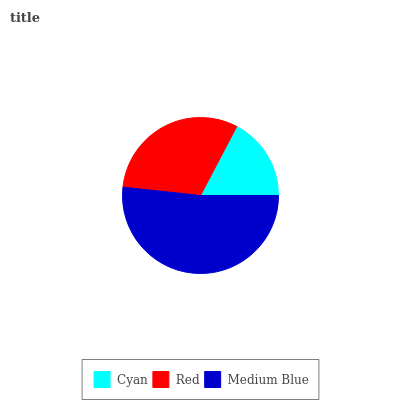Is Cyan the minimum?
Answer yes or no. Yes. Is Medium Blue the maximum?
Answer yes or no. Yes. Is Red the minimum?
Answer yes or no. No. Is Red the maximum?
Answer yes or no. No. Is Red greater than Cyan?
Answer yes or no. Yes. Is Cyan less than Red?
Answer yes or no. Yes. Is Cyan greater than Red?
Answer yes or no. No. Is Red less than Cyan?
Answer yes or no. No. Is Red the high median?
Answer yes or no. Yes. Is Red the low median?
Answer yes or no. Yes. Is Cyan the high median?
Answer yes or no. No. Is Cyan the low median?
Answer yes or no. No. 